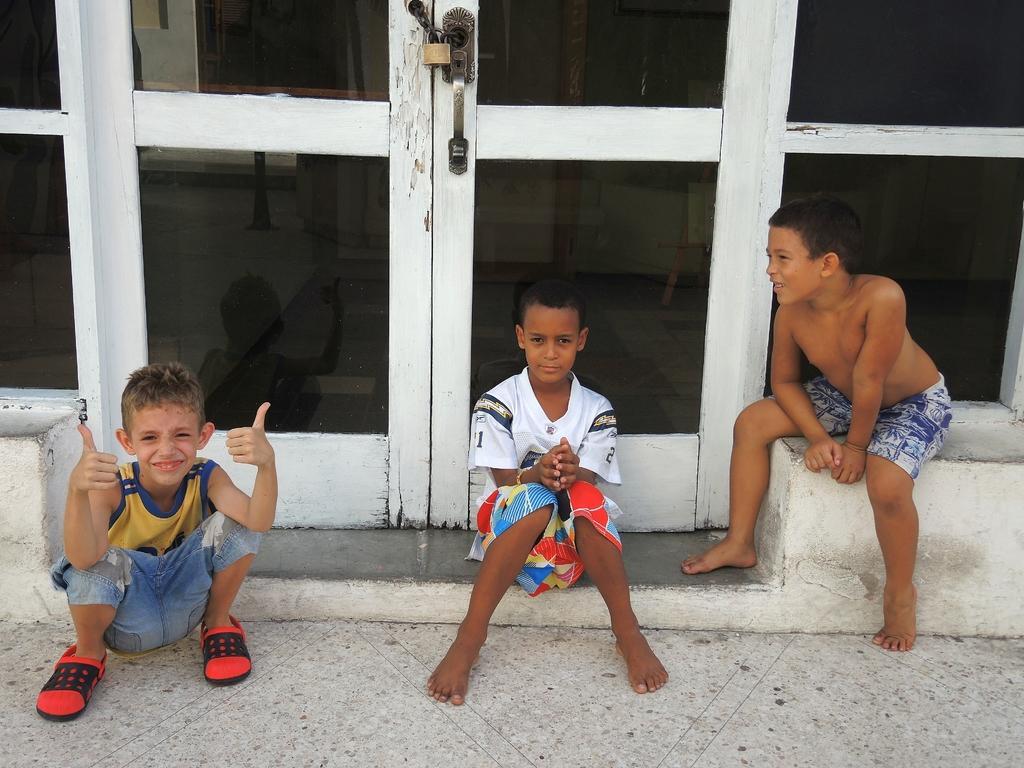In one or two sentences, can you explain what this image depicts? As we can see in the image there are doors and three people sitting in the front. 